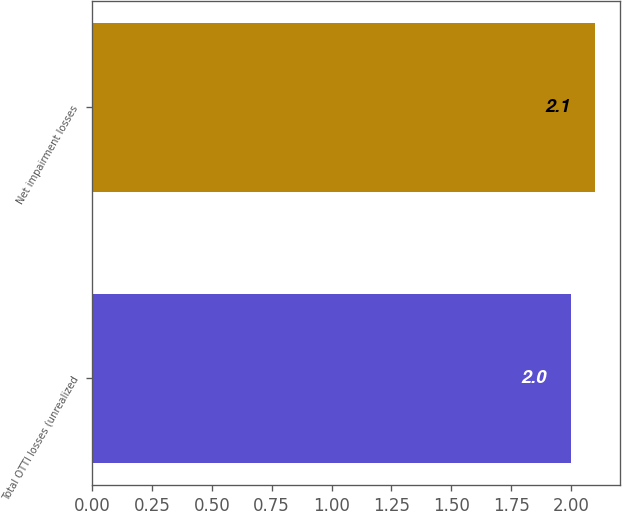Convert chart to OTSL. <chart><loc_0><loc_0><loc_500><loc_500><bar_chart><fcel>Total OTTI losses (unrealized<fcel>Net impairment losses<nl><fcel>2<fcel>2.1<nl></chart> 